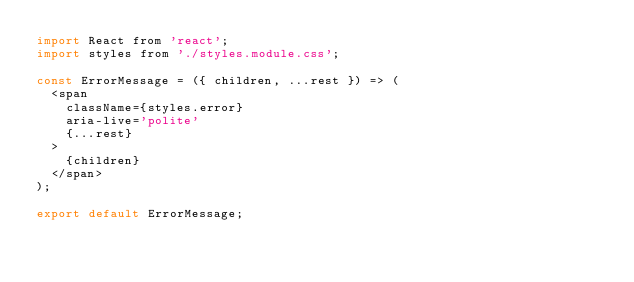<code> <loc_0><loc_0><loc_500><loc_500><_JavaScript_>import React from 'react';
import styles from './styles.module.css';

const ErrorMessage = ({ children, ...rest }) => (
  <span
    className={styles.error}
    aria-live='polite'
    {...rest}
  >
    {children}
  </span>
);

export default ErrorMessage;</code> 